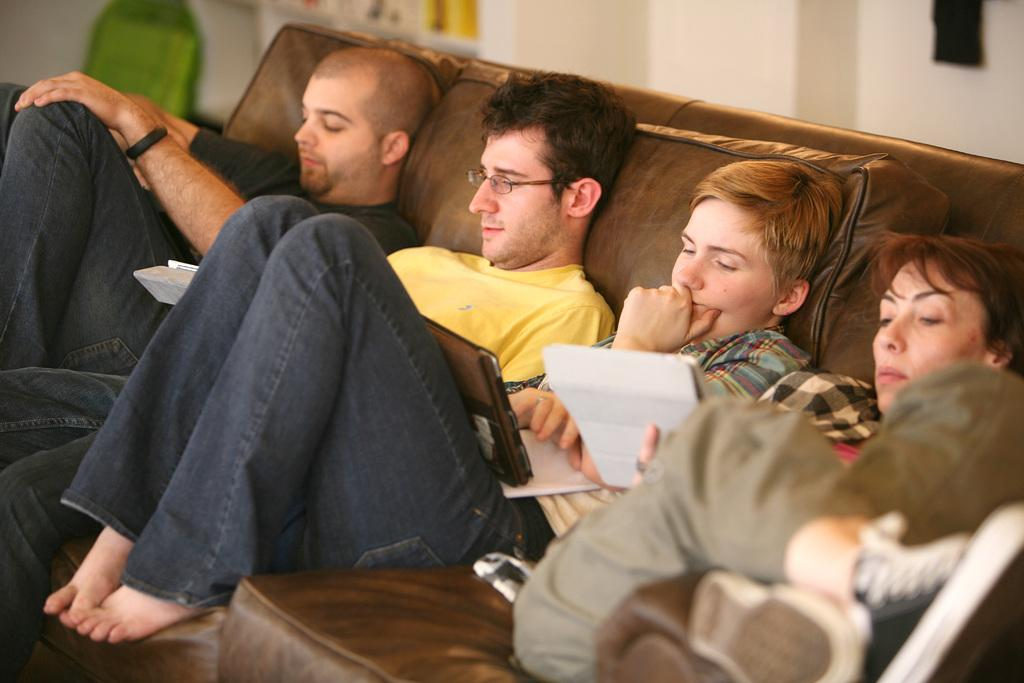What type of space is depicted in the image? The image is of a room. What color is the sofa in the room? There is a brown color sofa in the room. What are the people in the room doing? There is a group of people sitting on the sofa. What can be found inside the cupboard in the room? There are objects in a cupboard in the room. What is visible on the walls in the room? There is a wall visible in the room. What month is it in the image? The image does not provide any information about the month or time of year. Is there an island visible in the image? There is no island present in the image; it is a room with a brown sofa and a group of people sitting on it. 